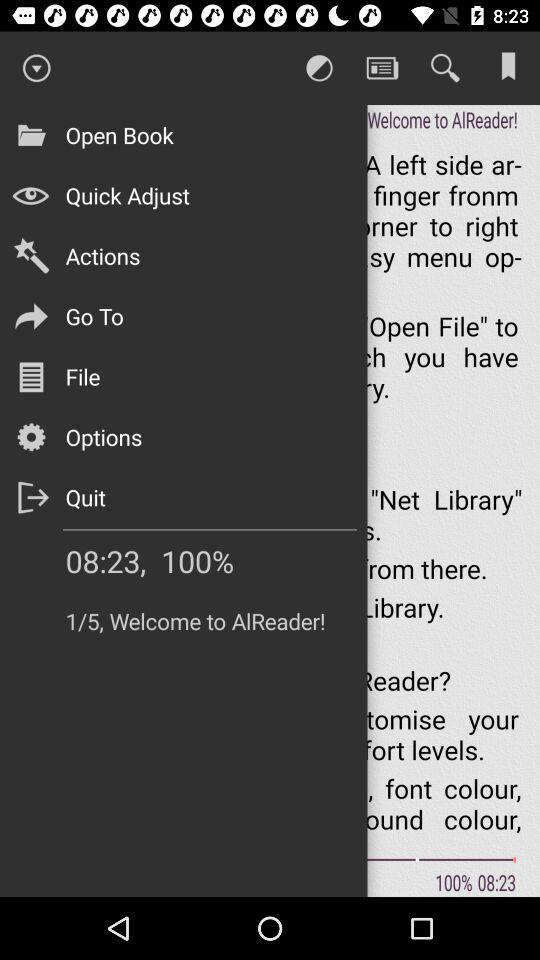What is the application name? The application name is "AlReader". 